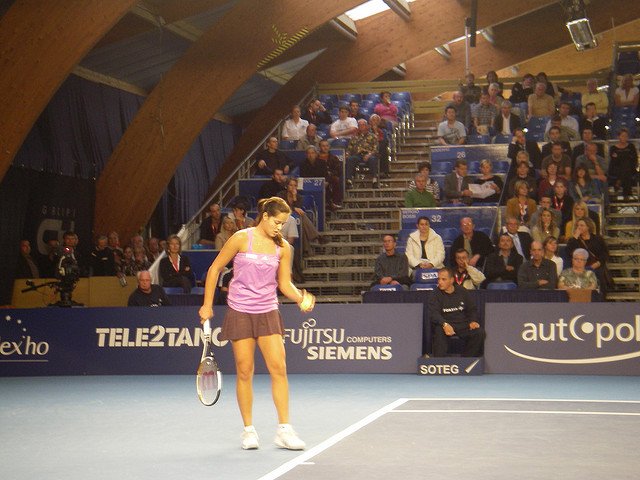Please extract the text content from this image. SIEMENS COMPUTERS FUJITSU TELE2TANC SOTEG exho po aut 